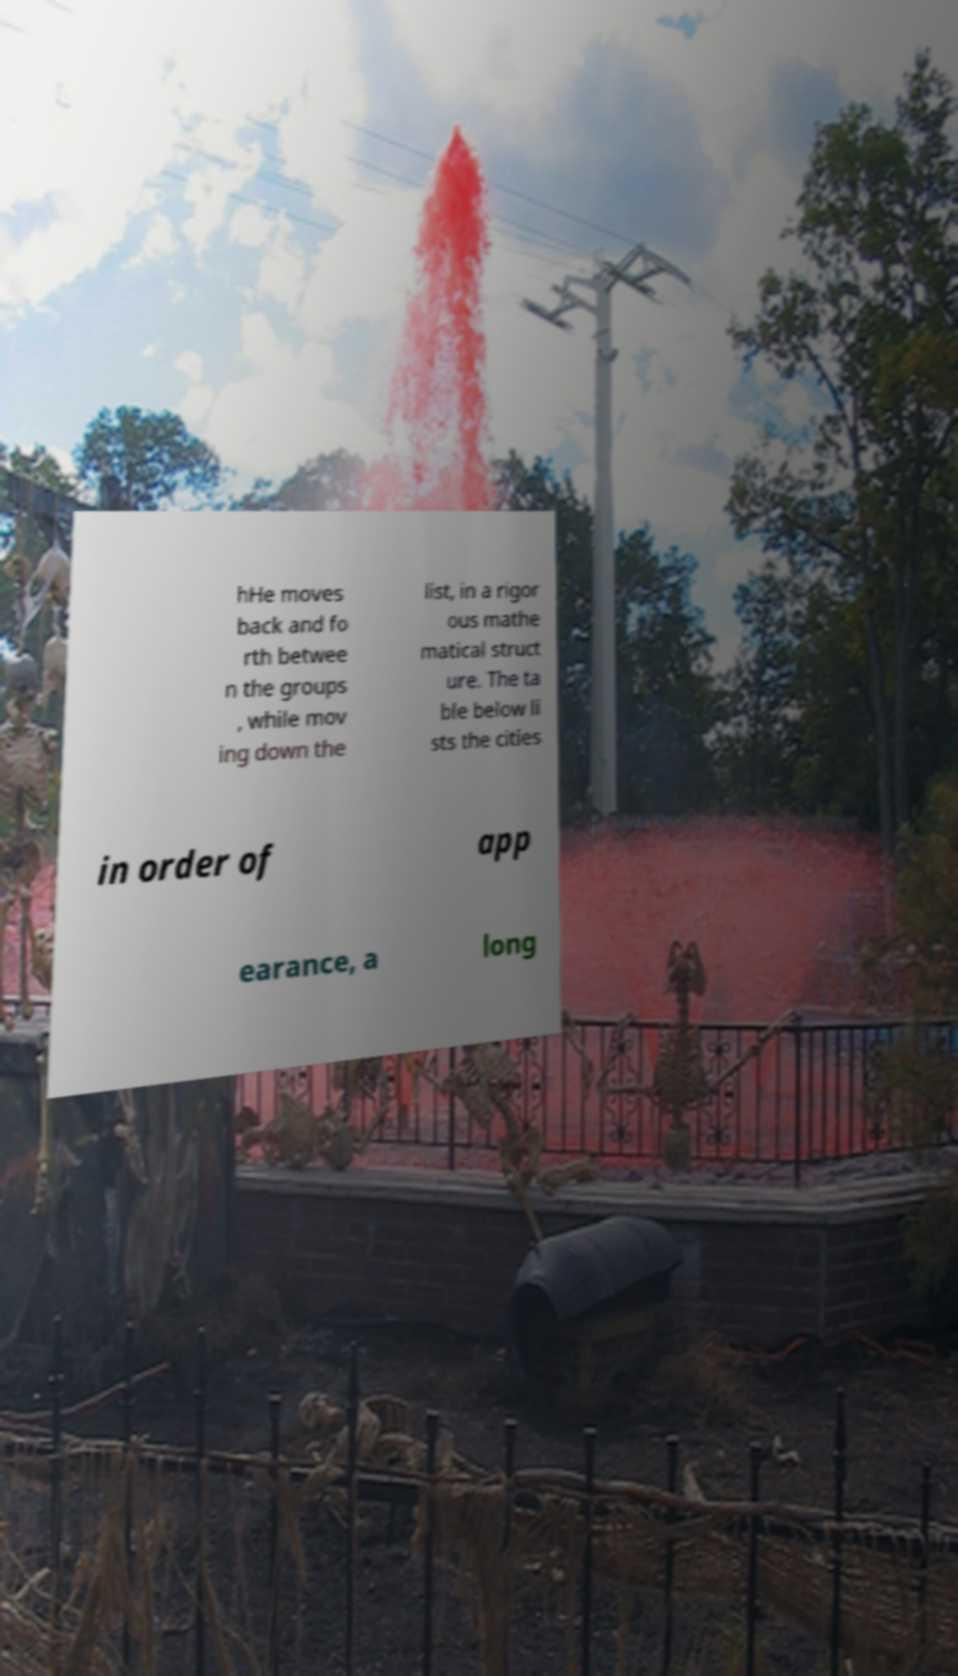I need the written content from this picture converted into text. Can you do that? hHe moves back and fo rth betwee n the groups , while mov ing down the list, in a rigor ous mathe matical struct ure. The ta ble below li sts the cities in order of app earance, a long 